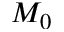Convert formula to latex. <formula><loc_0><loc_0><loc_500><loc_500>M _ { 0 }</formula> 